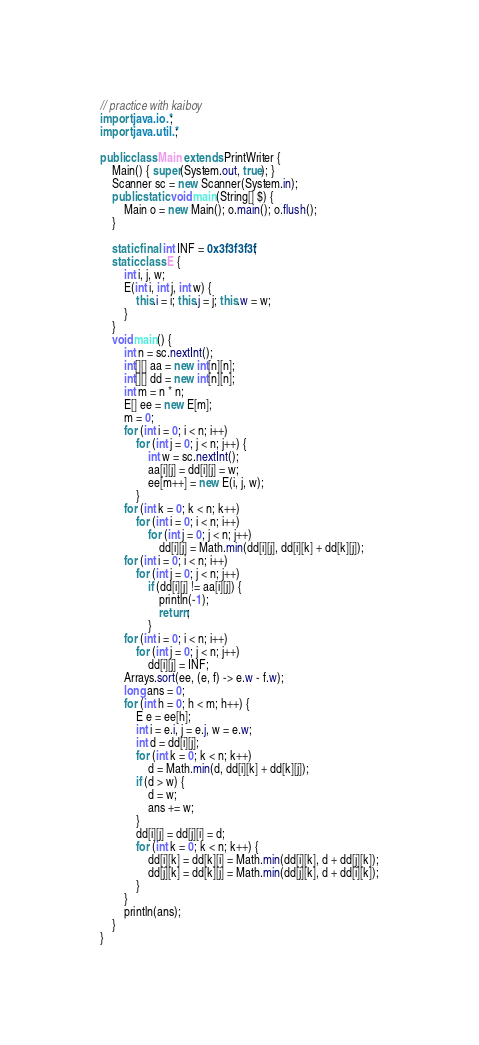Convert code to text. <code><loc_0><loc_0><loc_500><loc_500><_Java_>// practice with kaiboy
import java.io.*;
import java.util.*;

public class Main extends PrintWriter {
	Main() { super(System.out, true); }
	Scanner sc = new Scanner(System.in);
	public static void main(String[] $) {
		Main o = new Main(); o.main(); o.flush();
	}

	static final int INF = 0x3f3f3f3f;
	static class E {
		int i, j, w;
		E(int i, int j, int w) {
			this.i = i; this.j = j; this.w = w;
		}
	}
	void main() {
		int n = sc.nextInt();
		int[][] aa = new int[n][n];
		int[][] dd = new int[n][n];
		int m = n * n;
		E[] ee = new E[m];
		m = 0;
		for (int i = 0; i < n; i++)
			for (int j = 0; j < n; j++) {
				int w = sc.nextInt();
				aa[i][j] = dd[i][j] = w;
				ee[m++] = new E(i, j, w);
			}
		for (int k = 0; k < n; k++)
			for (int i = 0; i < n; i++)
				for (int j = 0; j < n; j++)
					dd[i][j] = Math.min(dd[i][j], dd[i][k] + dd[k][j]);
		for (int i = 0; i < n; i++)
			for (int j = 0; j < n; j++)
				if (dd[i][j] != aa[i][j]) {
					println(-1);
					return;
				}
		for (int i = 0; i < n; i++)
			for (int j = 0; j < n; j++)
				dd[i][j] = INF;
		Arrays.sort(ee, (e, f) -> e.w - f.w);
		long ans = 0;
		for (int h = 0; h < m; h++) {
			E e = ee[h];
			int i = e.i, j = e.j, w = e.w;
			int d = dd[i][j];
			for (int k = 0; k < n; k++)
				d = Math.min(d, dd[i][k] + dd[k][j]);
			if (d > w) {
				d = w;
				ans += w;
			}
			dd[i][j] = dd[j][i] = d;
			for (int k = 0; k < n; k++) {
				dd[i][k] = dd[k][i] = Math.min(dd[i][k], d + dd[j][k]);
				dd[j][k] = dd[k][j] = Math.min(dd[j][k], d + dd[i][k]);
			}
		}
		println(ans);
	}
}
</code> 